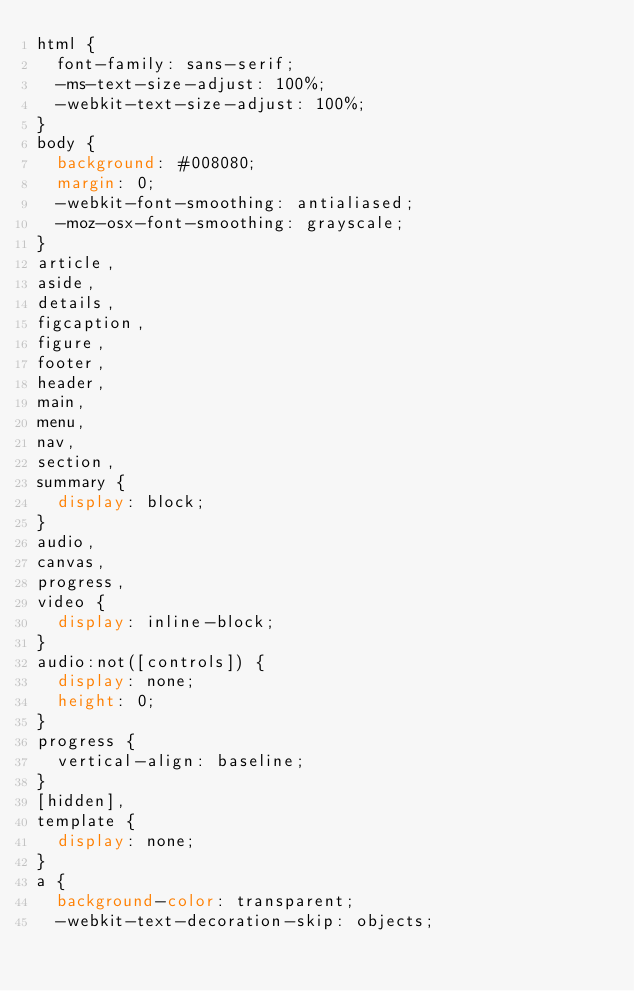<code> <loc_0><loc_0><loc_500><loc_500><_CSS_>html {
  font-family: sans-serif;
  -ms-text-size-adjust: 100%;
  -webkit-text-size-adjust: 100%;
}
body {
  background: #008080;
  margin: 0;
  -webkit-font-smoothing: antialiased;
  -moz-osx-font-smoothing: grayscale;
}
article,
aside,
details,
figcaption,
figure,
footer,
header,
main,
menu,
nav,
section,
summary {
  display: block;
}
audio,
canvas,
progress,
video {
  display: inline-block;
}
audio:not([controls]) {
  display: none;
  height: 0;
}
progress {
  vertical-align: baseline;
}
[hidden],
template {
  display: none;
}
a {
  background-color: transparent;
  -webkit-text-decoration-skip: objects;</code> 